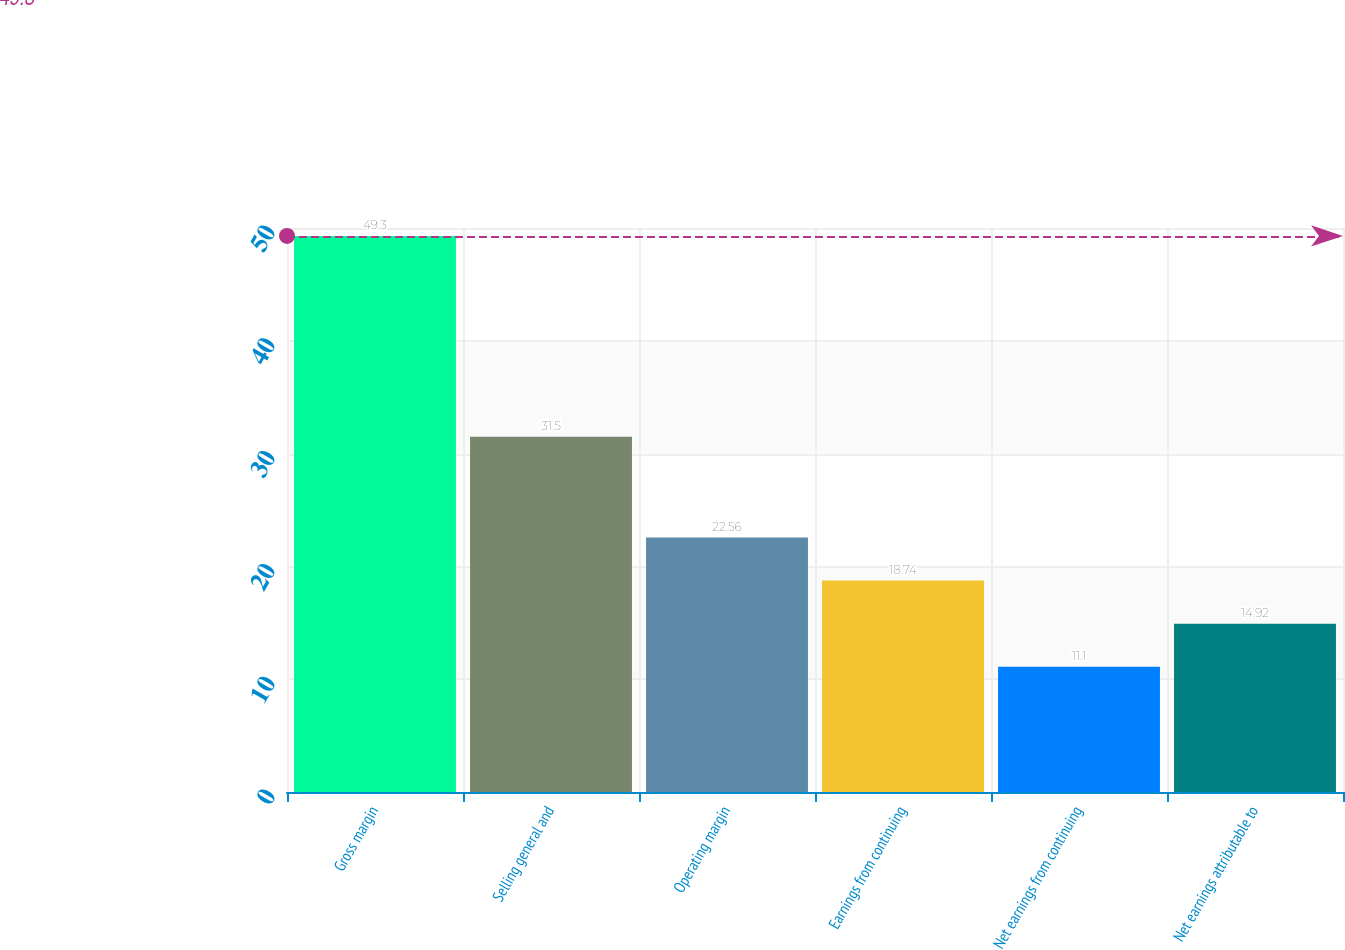<chart> <loc_0><loc_0><loc_500><loc_500><bar_chart><fcel>Gross margin<fcel>Selling general and<fcel>Operating margin<fcel>Earnings from continuing<fcel>Net earnings from continuing<fcel>Net earnings attributable to<nl><fcel>49.3<fcel>31.5<fcel>22.56<fcel>18.74<fcel>11.1<fcel>14.92<nl></chart> 